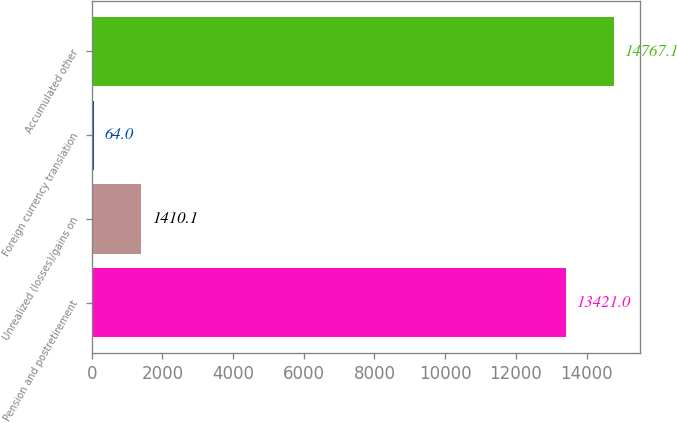<chart> <loc_0><loc_0><loc_500><loc_500><bar_chart><fcel>Pension and postretirement<fcel>Unrealized (losses)/gains on<fcel>Foreign currency translation<fcel>Accumulated other<nl><fcel>13421<fcel>1410.1<fcel>64<fcel>14767.1<nl></chart> 